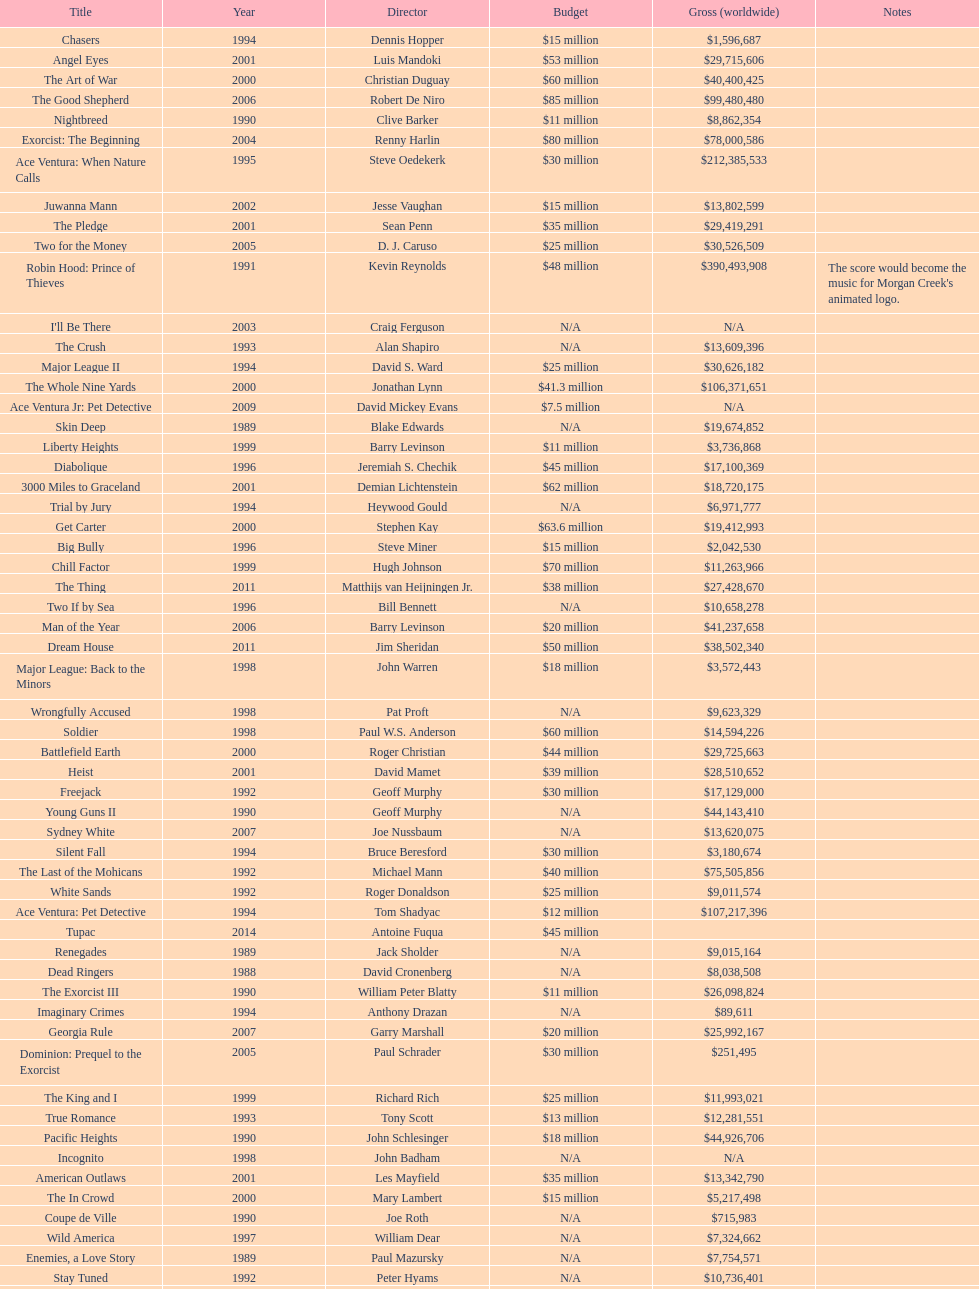Which morgan creek film grossed the most money prior to 1994? Robin Hood: Prince of Thieves. 